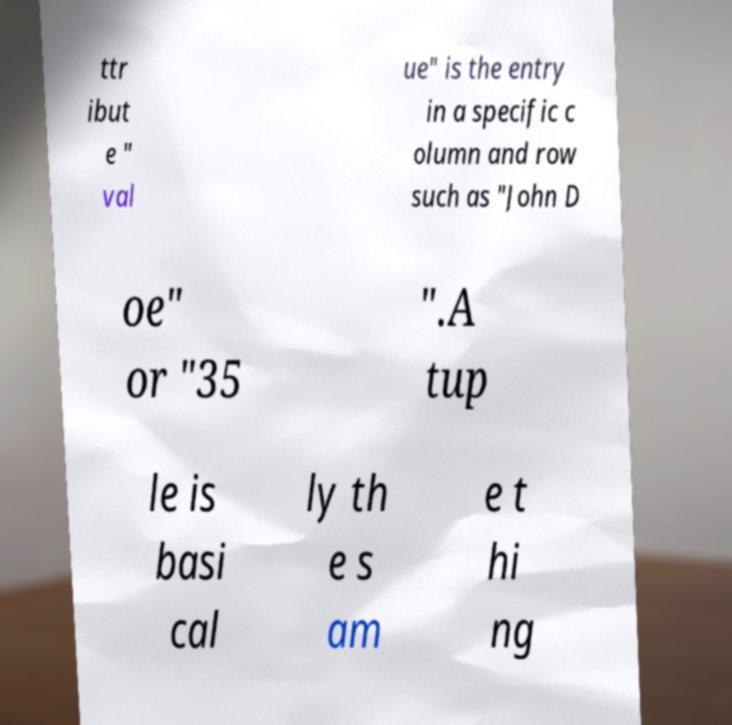Could you assist in decoding the text presented in this image and type it out clearly? ttr ibut e " val ue" is the entry in a specific c olumn and row such as "John D oe" or "35 ".A tup le is basi cal ly th e s am e t hi ng 